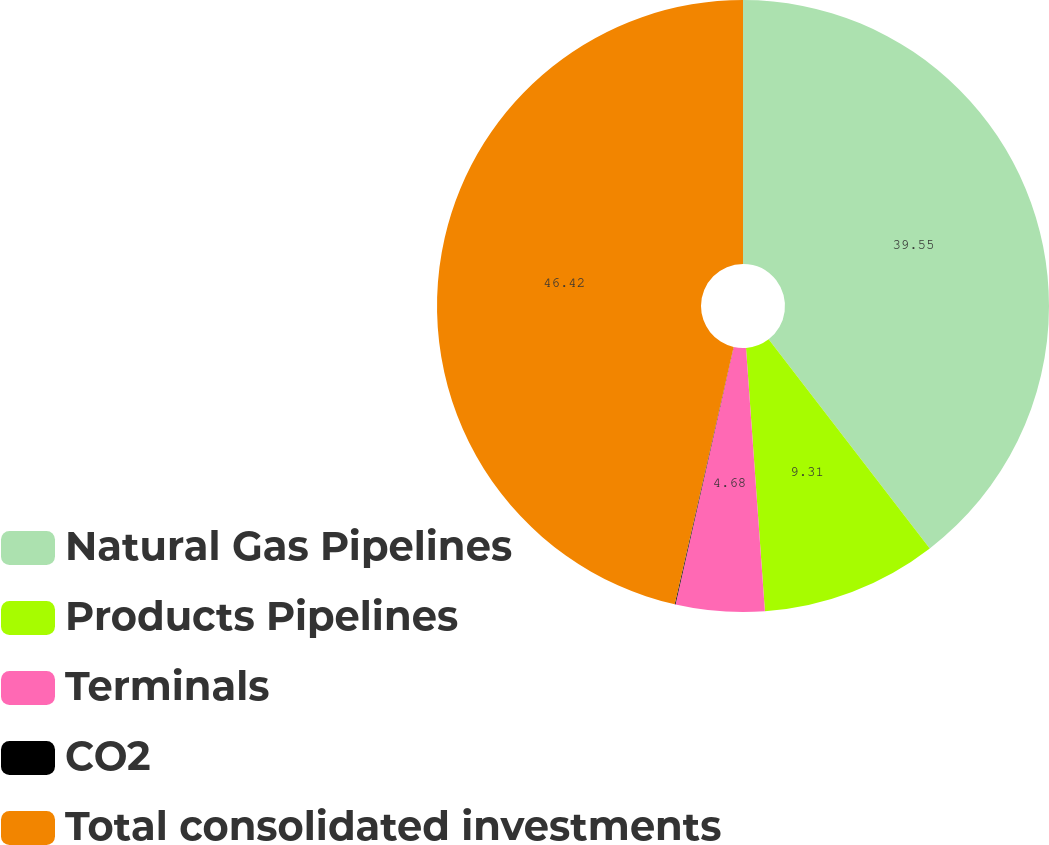<chart> <loc_0><loc_0><loc_500><loc_500><pie_chart><fcel>Natural Gas Pipelines<fcel>Products Pipelines<fcel>Terminals<fcel>CO2<fcel>Total consolidated investments<nl><fcel>39.55%<fcel>9.31%<fcel>4.68%<fcel>0.04%<fcel>46.42%<nl></chart> 